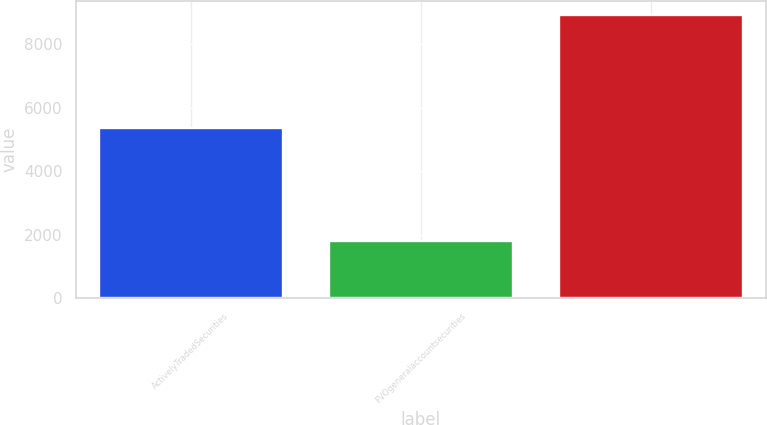Convert chart to OTSL. <chart><loc_0><loc_0><loc_500><loc_500><bar_chart><fcel>ActivelyTradedSecurities<fcel>FVOgeneralaccountsecurities<fcel>Unnamed: 2<nl><fcel>5370.4<fcel>1820.8<fcel>8920<nl></chart> 